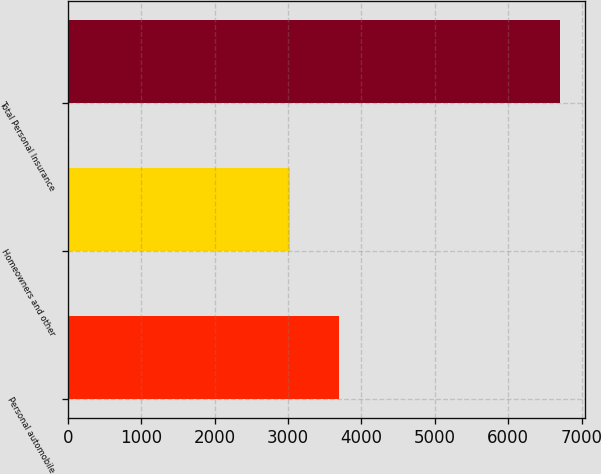<chart> <loc_0><loc_0><loc_500><loc_500><bar_chart><fcel>Personal automobile<fcel>Homeowners and other<fcel>Total Personal Insurance<nl><fcel>3692<fcel>3019<fcel>6711<nl></chart> 